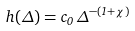<formula> <loc_0><loc_0><loc_500><loc_500>h ( \Delta ) = c _ { 0 } \, \Delta ^ { - ( 1 + \chi ) }</formula> 